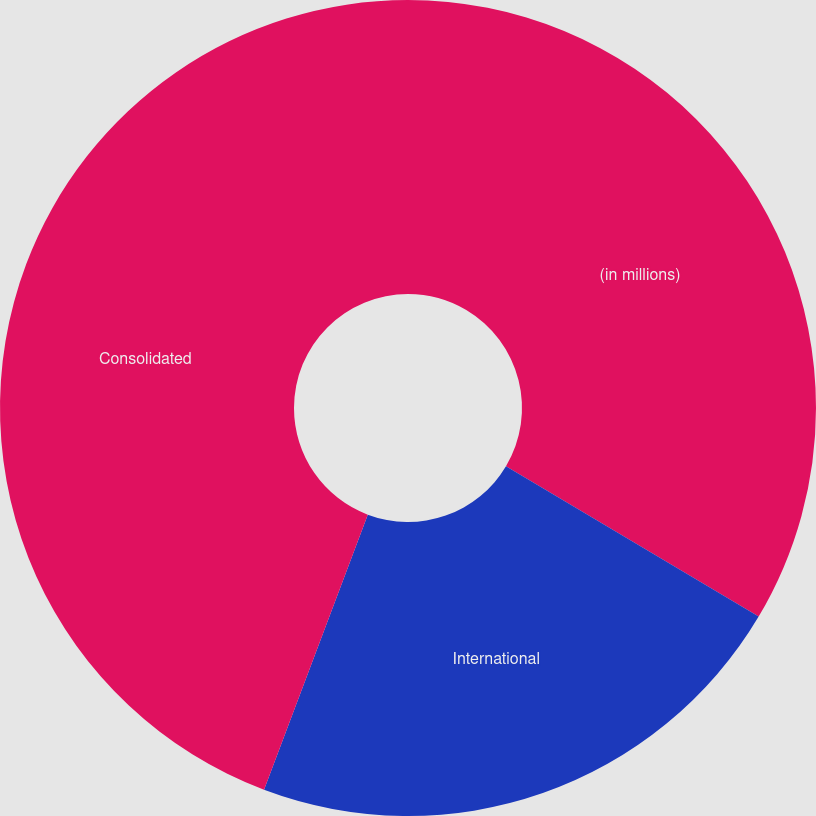Convert chart. <chart><loc_0><loc_0><loc_500><loc_500><pie_chart><fcel>(in millions)<fcel>International<fcel>Consolidated<nl><fcel>33.54%<fcel>22.2%<fcel>44.26%<nl></chart> 